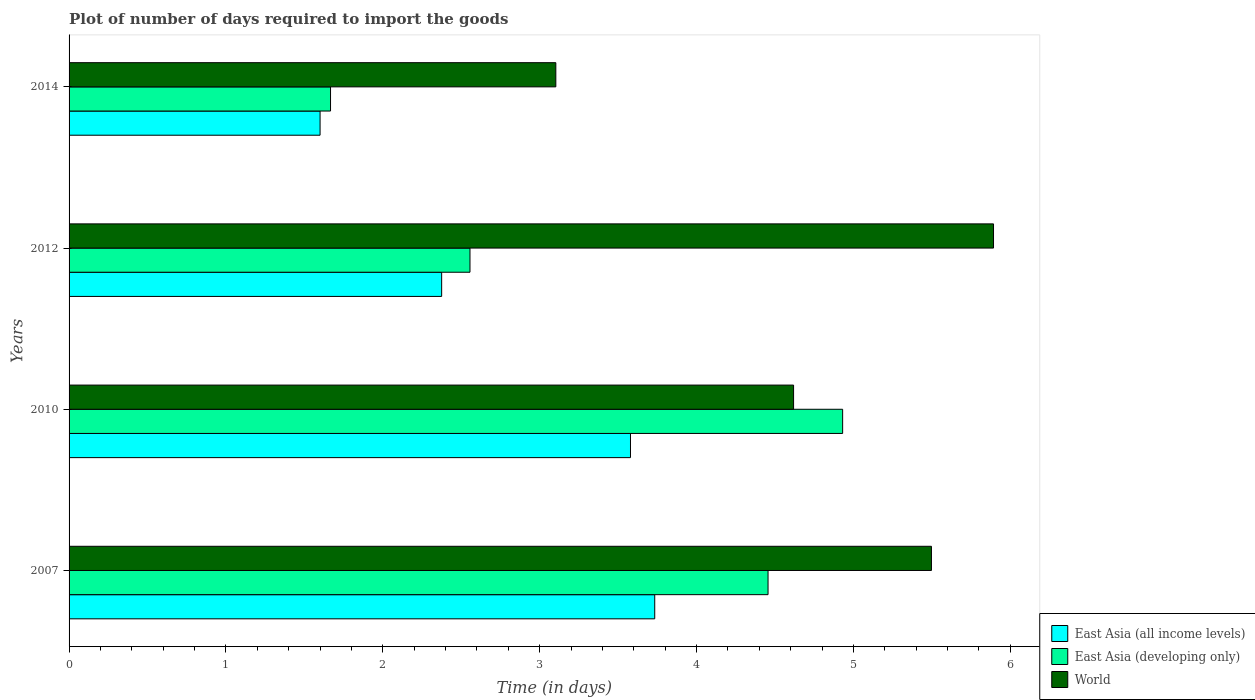How many groups of bars are there?
Make the answer very short. 4. Are the number of bars per tick equal to the number of legend labels?
Offer a very short reply. Yes. How many bars are there on the 1st tick from the bottom?
Keep it short and to the point. 3. What is the time required to import goods in World in 2010?
Your answer should be very brief. 4.62. Across all years, what is the maximum time required to import goods in East Asia (developing only)?
Make the answer very short. 4.93. Across all years, what is the minimum time required to import goods in East Asia (developing only)?
Offer a very short reply. 1.67. What is the total time required to import goods in East Asia (developing only) in the graph?
Keep it short and to the point. 13.61. What is the difference between the time required to import goods in East Asia (developing only) in 2007 and that in 2010?
Offer a terse response. -0.48. What is the difference between the time required to import goods in East Asia (developing only) in 2014 and the time required to import goods in World in 2012?
Your response must be concise. -4.23. What is the average time required to import goods in World per year?
Give a very brief answer. 4.78. In the year 2014, what is the difference between the time required to import goods in East Asia (all income levels) and time required to import goods in World?
Offer a very short reply. -1.5. What is the ratio of the time required to import goods in East Asia (developing only) in 2007 to that in 2010?
Offer a very short reply. 0.9. What is the difference between the highest and the second highest time required to import goods in East Asia (developing only)?
Make the answer very short. 0.48. What is the difference between the highest and the lowest time required to import goods in East Asia (all income levels)?
Your answer should be compact. 2.13. In how many years, is the time required to import goods in East Asia (developing only) greater than the average time required to import goods in East Asia (developing only) taken over all years?
Offer a very short reply. 2. Is the sum of the time required to import goods in World in 2007 and 2010 greater than the maximum time required to import goods in East Asia (developing only) across all years?
Keep it short and to the point. Yes. What does the 3rd bar from the top in 2014 represents?
Make the answer very short. East Asia (all income levels). What does the 1st bar from the bottom in 2010 represents?
Provide a succinct answer. East Asia (all income levels). Is it the case that in every year, the sum of the time required to import goods in East Asia (developing only) and time required to import goods in East Asia (all income levels) is greater than the time required to import goods in World?
Provide a short and direct response. No. Are all the bars in the graph horizontal?
Provide a succinct answer. Yes. How are the legend labels stacked?
Your answer should be very brief. Vertical. What is the title of the graph?
Provide a short and direct response. Plot of number of days required to import the goods. What is the label or title of the X-axis?
Give a very brief answer. Time (in days). What is the label or title of the Y-axis?
Your response must be concise. Years. What is the Time (in days) of East Asia (all income levels) in 2007?
Your answer should be compact. 3.73. What is the Time (in days) in East Asia (developing only) in 2007?
Your answer should be compact. 4.46. What is the Time (in days) in World in 2007?
Ensure brevity in your answer.  5.5. What is the Time (in days) of East Asia (all income levels) in 2010?
Keep it short and to the point. 3.58. What is the Time (in days) of East Asia (developing only) in 2010?
Offer a terse response. 4.93. What is the Time (in days) of World in 2010?
Offer a very short reply. 4.62. What is the Time (in days) in East Asia (all income levels) in 2012?
Your answer should be compact. 2.38. What is the Time (in days) of East Asia (developing only) in 2012?
Offer a terse response. 2.56. What is the Time (in days) in World in 2012?
Offer a terse response. 5.89. What is the Time (in days) of East Asia (developing only) in 2014?
Make the answer very short. 1.67. What is the Time (in days) in World in 2014?
Provide a succinct answer. 3.1. Across all years, what is the maximum Time (in days) of East Asia (all income levels)?
Keep it short and to the point. 3.73. Across all years, what is the maximum Time (in days) of East Asia (developing only)?
Offer a terse response. 4.93. Across all years, what is the maximum Time (in days) in World?
Your answer should be compact. 5.89. Across all years, what is the minimum Time (in days) of East Asia (all income levels)?
Ensure brevity in your answer.  1.6. Across all years, what is the minimum Time (in days) of East Asia (developing only)?
Your answer should be compact. 1.67. Across all years, what is the minimum Time (in days) in World?
Make the answer very short. 3.1. What is the total Time (in days) of East Asia (all income levels) in the graph?
Offer a terse response. 11.29. What is the total Time (in days) of East Asia (developing only) in the graph?
Provide a succinct answer. 13.61. What is the total Time (in days) of World in the graph?
Give a very brief answer. 19.11. What is the difference between the Time (in days) in East Asia (all income levels) in 2007 and that in 2010?
Provide a short and direct response. 0.15. What is the difference between the Time (in days) of East Asia (developing only) in 2007 and that in 2010?
Provide a succinct answer. -0.48. What is the difference between the Time (in days) in World in 2007 and that in 2010?
Your response must be concise. 0.88. What is the difference between the Time (in days) of East Asia (all income levels) in 2007 and that in 2012?
Give a very brief answer. 1.36. What is the difference between the Time (in days) of World in 2007 and that in 2012?
Your answer should be very brief. -0.4. What is the difference between the Time (in days) in East Asia (all income levels) in 2007 and that in 2014?
Offer a terse response. 2.13. What is the difference between the Time (in days) of East Asia (developing only) in 2007 and that in 2014?
Your answer should be very brief. 2.79. What is the difference between the Time (in days) of World in 2007 and that in 2014?
Make the answer very short. 2.39. What is the difference between the Time (in days) of East Asia (all income levels) in 2010 and that in 2012?
Provide a succinct answer. 1.2. What is the difference between the Time (in days) in East Asia (developing only) in 2010 and that in 2012?
Provide a succinct answer. 2.38. What is the difference between the Time (in days) of World in 2010 and that in 2012?
Offer a very short reply. -1.27. What is the difference between the Time (in days) of East Asia (all income levels) in 2010 and that in 2014?
Your response must be concise. 1.98. What is the difference between the Time (in days) in East Asia (developing only) in 2010 and that in 2014?
Your answer should be very brief. 3.26. What is the difference between the Time (in days) of World in 2010 and that in 2014?
Your answer should be very brief. 1.52. What is the difference between the Time (in days) of East Asia (all income levels) in 2012 and that in 2014?
Your response must be concise. 0.78. What is the difference between the Time (in days) in East Asia (developing only) in 2012 and that in 2014?
Offer a very short reply. 0.89. What is the difference between the Time (in days) of World in 2012 and that in 2014?
Offer a terse response. 2.79. What is the difference between the Time (in days) in East Asia (all income levels) in 2007 and the Time (in days) in East Asia (developing only) in 2010?
Your response must be concise. -1.2. What is the difference between the Time (in days) in East Asia (all income levels) in 2007 and the Time (in days) in World in 2010?
Ensure brevity in your answer.  -0.89. What is the difference between the Time (in days) of East Asia (developing only) in 2007 and the Time (in days) of World in 2010?
Ensure brevity in your answer.  -0.16. What is the difference between the Time (in days) of East Asia (all income levels) in 2007 and the Time (in days) of East Asia (developing only) in 2012?
Keep it short and to the point. 1.18. What is the difference between the Time (in days) in East Asia (all income levels) in 2007 and the Time (in days) in World in 2012?
Provide a succinct answer. -2.16. What is the difference between the Time (in days) in East Asia (developing only) in 2007 and the Time (in days) in World in 2012?
Keep it short and to the point. -1.44. What is the difference between the Time (in days) in East Asia (all income levels) in 2007 and the Time (in days) in East Asia (developing only) in 2014?
Provide a succinct answer. 2.07. What is the difference between the Time (in days) in East Asia (all income levels) in 2007 and the Time (in days) in World in 2014?
Make the answer very short. 0.63. What is the difference between the Time (in days) of East Asia (developing only) in 2007 and the Time (in days) of World in 2014?
Ensure brevity in your answer.  1.35. What is the difference between the Time (in days) of East Asia (all income levels) in 2010 and the Time (in days) of East Asia (developing only) in 2012?
Make the answer very short. 1.02. What is the difference between the Time (in days) in East Asia (all income levels) in 2010 and the Time (in days) in World in 2012?
Provide a short and direct response. -2.31. What is the difference between the Time (in days) in East Asia (developing only) in 2010 and the Time (in days) in World in 2012?
Keep it short and to the point. -0.96. What is the difference between the Time (in days) in East Asia (all income levels) in 2010 and the Time (in days) in East Asia (developing only) in 2014?
Ensure brevity in your answer.  1.91. What is the difference between the Time (in days) of East Asia (all income levels) in 2010 and the Time (in days) of World in 2014?
Provide a succinct answer. 0.48. What is the difference between the Time (in days) in East Asia (developing only) in 2010 and the Time (in days) in World in 2014?
Your answer should be compact. 1.83. What is the difference between the Time (in days) of East Asia (all income levels) in 2012 and the Time (in days) of East Asia (developing only) in 2014?
Provide a succinct answer. 0.71. What is the difference between the Time (in days) in East Asia (all income levels) in 2012 and the Time (in days) in World in 2014?
Keep it short and to the point. -0.73. What is the difference between the Time (in days) of East Asia (developing only) in 2012 and the Time (in days) of World in 2014?
Your response must be concise. -0.55. What is the average Time (in days) in East Asia (all income levels) per year?
Offer a terse response. 2.82. What is the average Time (in days) of East Asia (developing only) per year?
Make the answer very short. 3.4. What is the average Time (in days) in World per year?
Keep it short and to the point. 4.78. In the year 2007, what is the difference between the Time (in days) of East Asia (all income levels) and Time (in days) of East Asia (developing only)?
Keep it short and to the point. -0.72. In the year 2007, what is the difference between the Time (in days) in East Asia (all income levels) and Time (in days) in World?
Your answer should be compact. -1.76. In the year 2007, what is the difference between the Time (in days) of East Asia (developing only) and Time (in days) of World?
Make the answer very short. -1.04. In the year 2010, what is the difference between the Time (in days) of East Asia (all income levels) and Time (in days) of East Asia (developing only)?
Offer a terse response. -1.35. In the year 2010, what is the difference between the Time (in days) in East Asia (all income levels) and Time (in days) in World?
Make the answer very short. -1.04. In the year 2010, what is the difference between the Time (in days) in East Asia (developing only) and Time (in days) in World?
Provide a short and direct response. 0.31. In the year 2012, what is the difference between the Time (in days) in East Asia (all income levels) and Time (in days) in East Asia (developing only)?
Offer a very short reply. -0.18. In the year 2012, what is the difference between the Time (in days) of East Asia (all income levels) and Time (in days) of World?
Ensure brevity in your answer.  -3.52. In the year 2012, what is the difference between the Time (in days) in East Asia (developing only) and Time (in days) in World?
Your answer should be very brief. -3.34. In the year 2014, what is the difference between the Time (in days) in East Asia (all income levels) and Time (in days) in East Asia (developing only)?
Make the answer very short. -0.07. In the year 2014, what is the difference between the Time (in days) of East Asia (all income levels) and Time (in days) of World?
Your answer should be very brief. -1.5. In the year 2014, what is the difference between the Time (in days) in East Asia (developing only) and Time (in days) in World?
Your response must be concise. -1.44. What is the ratio of the Time (in days) of East Asia (all income levels) in 2007 to that in 2010?
Give a very brief answer. 1.04. What is the ratio of the Time (in days) in East Asia (developing only) in 2007 to that in 2010?
Ensure brevity in your answer.  0.9. What is the ratio of the Time (in days) in World in 2007 to that in 2010?
Offer a very short reply. 1.19. What is the ratio of the Time (in days) of East Asia (all income levels) in 2007 to that in 2012?
Provide a succinct answer. 1.57. What is the ratio of the Time (in days) in East Asia (developing only) in 2007 to that in 2012?
Your response must be concise. 1.74. What is the ratio of the Time (in days) of World in 2007 to that in 2012?
Make the answer very short. 0.93. What is the ratio of the Time (in days) in East Asia (all income levels) in 2007 to that in 2014?
Offer a very short reply. 2.33. What is the ratio of the Time (in days) of East Asia (developing only) in 2007 to that in 2014?
Provide a succinct answer. 2.67. What is the ratio of the Time (in days) in World in 2007 to that in 2014?
Provide a short and direct response. 1.77. What is the ratio of the Time (in days) in East Asia (all income levels) in 2010 to that in 2012?
Your answer should be compact. 1.51. What is the ratio of the Time (in days) of East Asia (developing only) in 2010 to that in 2012?
Ensure brevity in your answer.  1.93. What is the ratio of the Time (in days) of World in 2010 to that in 2012?
Offer a terse response. 0.78. What is the ratio of the Time (in days) in East Asia (all income levels) in 2010 to that in 2014?
Provide a short and direct response. 2.24. What is the ratio of the Time (in days) of East Asia (developing only) in 2010 to that in 2014?
Offer a terse response. 2.96. What is the ratio of the Time (in days) of World in 2010 to that in 2014?
Give a very brief answer. 1.49. What is the ratio of the Time (in days) of East Asia (all income levels) in 2012 to that in 2014?
Give a very brief answer. 1.48. What is the ratio of the Time (in days) in East Asia (developing only) in 2012 to that in 2014?
Keep it short and to the point. 1.53. What is the ratio of the Time (in days) in World in 2012 to that in 2014?
Your response must be concise. 1.9. What is the difference between the highest and the second highest Time (in days) in East Asia (all income levels)?
Keep it short and to the point. 0.15. What is the difference between the highest and the second highest Time (in days) of East Asia (developing only)?
Your answer should be compact. 0.48. What is the difference between the highest and the second highest Time (in days) in World?
Offer a very short reply. 0.4. What is the difference between the highest and the lowest Time (in days) of East Asia (all income levels)?
Ensure brevity in your answer.  2.13. What is the difference between the highest and the lowest Time (in days) of East Asia (developing only)?
Provide a short and direct response. 3.26. What is the difference between the highest and the lowest Time (in days) of World?
Your answer should be very brief. 2.79. 